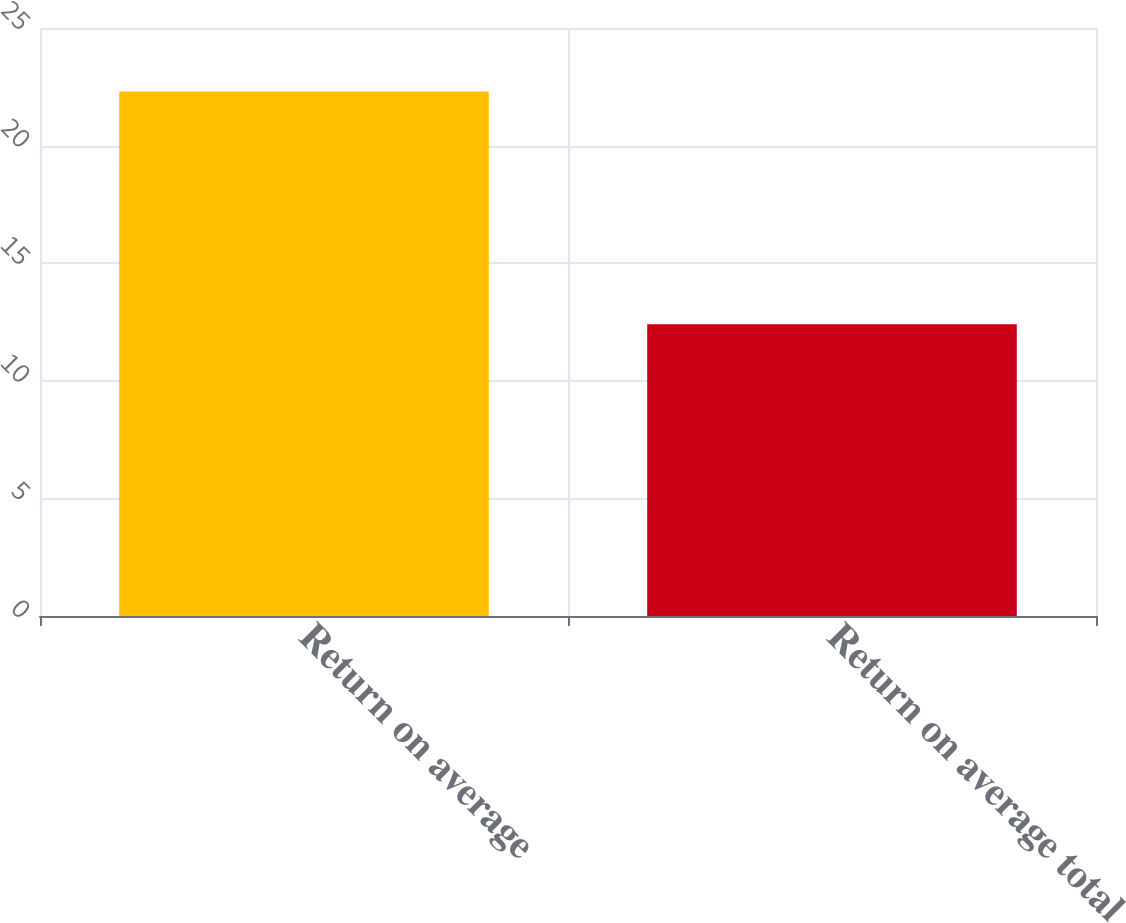<chart> <loc_0><loc_0><loc_500><loc_500><bar_chart><fcel>Return on average<fcel>Return on average total<nl><fcel>22.3<fcel>12.4<nl></chart> 